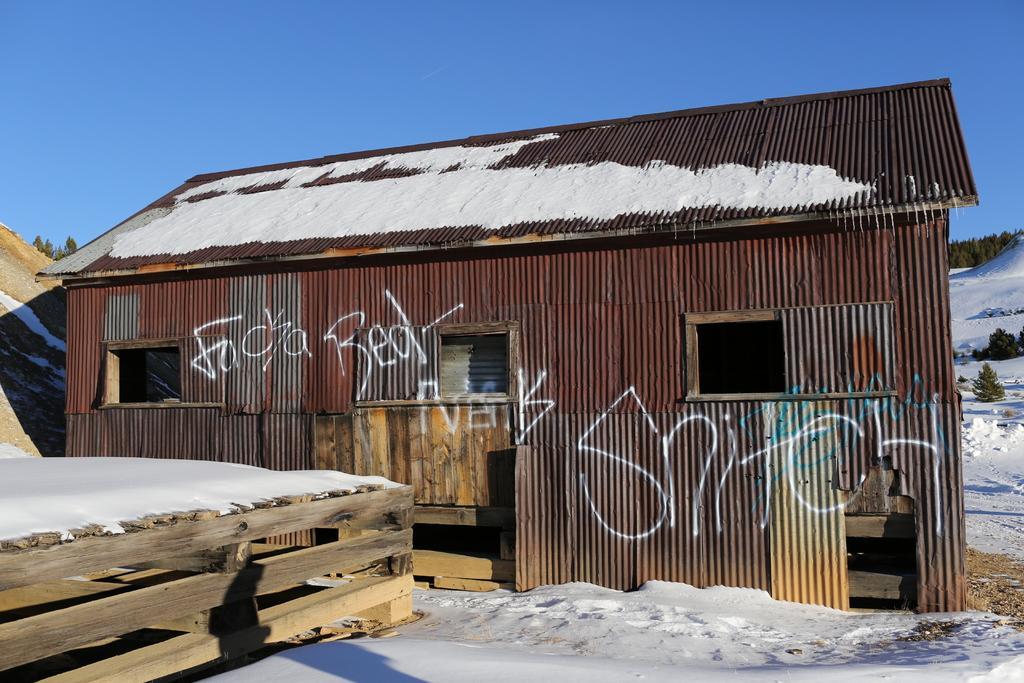Can you describe this image briefly? In this image we can see a shed with windows. On the shed there are words. On the ground there is snow. Also there is a wooden fencing. In the back we can see trees and sky. 